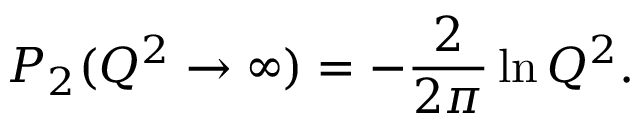Convert formula to latex. <formula><loc_0><loc_0><loc_500><loc_500>P _ { 2 } ( Q ^ { 2 } \rightarrow \infty ) = - \frac { 2 } { 2 \pi } \ln Q ^ { 2 } .</formula> 